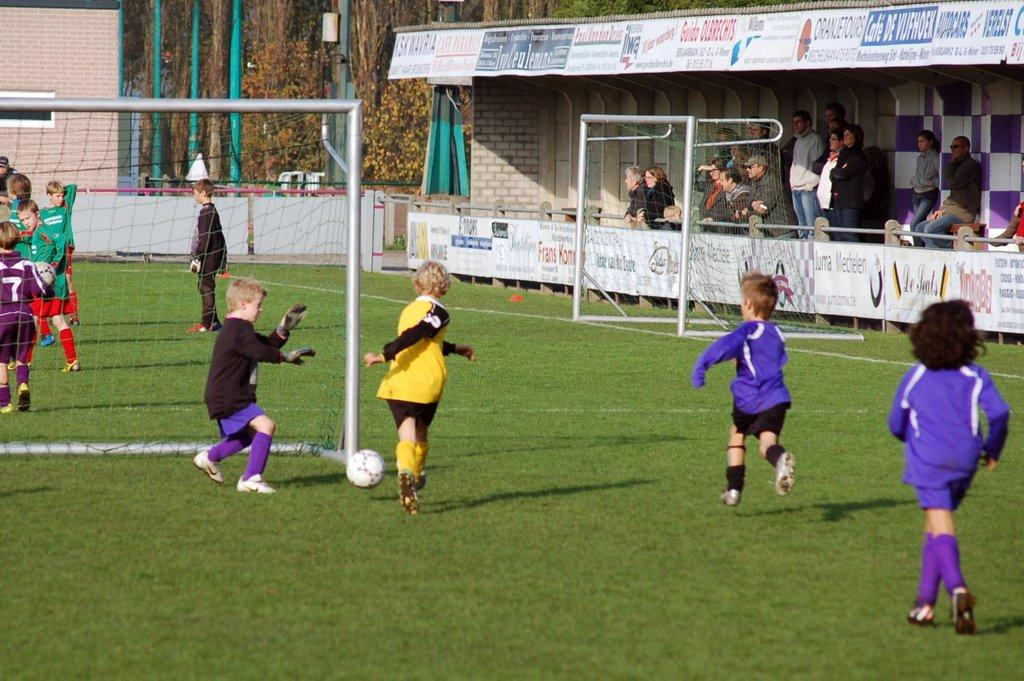<image>
Offer a succinct explanation of the picture presented. Children pay soccer in front of an ad for Cafe De Vijfhoek. 